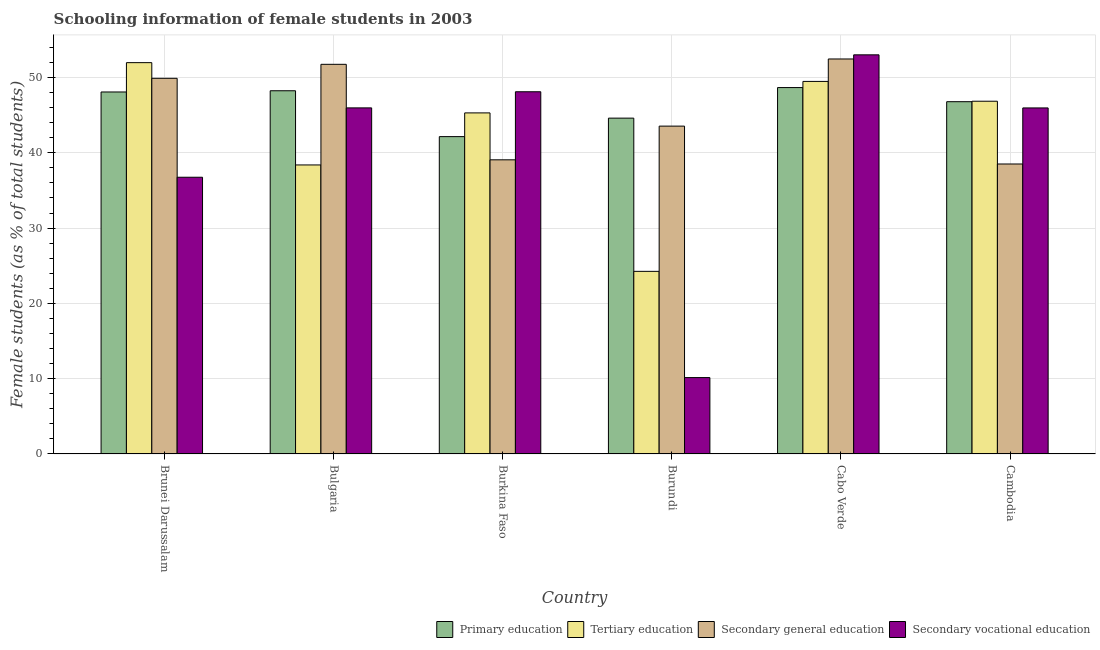How many different coloured bars are there?
Make the answer very short. 4. How many groups of bars are there?
Your response must be concise. 6. Are the number of bars on each tick of the X-axis equal?
Offer a very short reply. Yes. How many bars are there on the 5th tick from the left?
Offer a terse response. 4. What is the label of the 6th group of bars from the left?
Ensure brevity in your answer.  Cambodia. What is the percentage of female students in tertiary education in Cambodia?
Your answer should be compact. 46.85. Across all countries, what is the maximum percentage of female students in secondary vocational education?
Offer a very short reply. 53.01. Across all countries, what is the minimum percentage of female students in secondary education?
Give a very brief answer. 38.51. In which country was the percentage of female students in secondary education maximum?
Your answer should be compact. Cabo Verde. In which country was the percentage of female students in secondary education minimum?
Keep it short and to the point. Cambodia. What is the total percentage of female students in tertiary education in the graph?
Provide a short and direct response. 256.22. What is the difference between the percentage of female students in secondary education in Bulgaria and that in Burkina Faso?
Make the answer very short. 12.68. What is the difference between the percentage of female students in tertiary education in Burundi and the percentage of female students in primary education in Cabo Verde?
Make the answer very short. -24.41. What is the average percentage of female students in primary education per country?
Your response must be concise. 46.42. What is the difference between the percentage of female students in secondary education and percentage of female students in secondary vocational education in Cabo Verde?
Keep it short and to the point. -0.55. What is the ratio of the percentage of female students in secondary vocational education in Cabo Verde to that in Cambodia?
Your answer should be very brief. 1.15. What is the difference between the highest and the second highest percentage of female students in secondary education?
Keep it short and to the point. 0.71. What is the difference between the highest and the lowest percentage of female students in secondary education?
Your response must be concise. 13.95. Is it the case that in every country, the sum of the percentage of female students in secondary vocational education and percentage of female students in tertiary education is greater than the sum of percentage of female students in primary education and percentage of female students in secondary education?
Make the answer very short. No. What does the 4th bar from the left in Cambodia represents?
Your response must be concise. Secondary vocational education. What does the 3rd bar from the right in Cambodia represents?
Your answer should be very brief. Tertiary education. How many bars are there?
Provide a succinct answer. 24. What is the difference between two consecutive major ticks on the Y-axis?
Keep it short and to the point. 10. Are the values on the major ticks of Y-axis written in scientific E-notation?
Offer a very short reply. No. Does the graph contain grids?
Give a very brief answer. Yes. Where does the legend appear in the graph?
Offer a very short reply. Bottom right. How many legend labels are there?
Offer a terse response. 4. What is the title of the graph?
Ensure brevity in your answer.  Schooling information of female students in 2003. Does "Fish species" appear as one of the legend labels in the graph?
Your response must be concise. No. What is the label or title of the Y-axis?
Keep it short and to the point. Female students (as % of total students). What is the Female students (as % of total students) in Primary education in Brunei Darussalam?
Offer a very short reply. 48.07. What is the Female students (as % of total students) in Tertiary education in Brunei Darussalam?
Your answer should be very brief. 51.97. What is the Female students (as % of total students) of Secondary general education in Brunei Darussalam?
Provide a short and direct response. 49.89. What is the Female students (as % of total students) of Secondary vocational education in Brunei Darussalam?
Give a very brief answer. 36.75. What is the Female students (as % of total students) in Primary education in Bulgaria?
Your answer should be compact. 48.24. What is the Female students (as % of total students) in Tertiary education in Bulgaria?
Give a very brief answer. 38.38. What is the Female students (as % of total students) of Secondary general education in Bulgaria?
Your response must be concise. 51.75. What is the Female students (as % of total students) in Secondary vocational education in Bulgaria?
Your answer should be compact. 45.96. What is the Female students (as % of total students) of Primary education in Burkina Faso?
Make the answer very short. 42.15. What is the Female students (as % of total students) in Tertiary education in Burkina Faso?
Make the answer very short. 45.29. What is the Female students (as % of total students) in Secondary general education in Burkina Faso?
Offer a very short reply. 39.06. What is the Female students (as % of total students) in Secondary vocational education in Burkina Faso?
Provide a short and direct response. 48.1. What is the Female students (as % of total students) of Primary education in Burundi?
Your answer should be compact. 44.6. What is the Female students (as % of total students) in Tertiary education in Burundi?
Offer a terse response. 24.25. What is the Female students (as % of total students) of Secondary general education in Burundi?
Provide a short and direct response. 43.54. What is the Female students (as % of total students) in Secondary vocational education in Burundi?
Offer a very short reply. 10.14. What is the Female students (as % of total students) of Primary education in Cabo Verde?
Your answer should be compact. 48.66. What is the Female students (as % of total students) of Tertiary education in Cabo Verde?
Your response must be concise. 49.48. What is the Female students (as % of total students) of Secondary general education in Cabo Verde?
Offer a very short reply. 52.46. What is the Female students (as % of total students) in Secondary vocational education in Cabo Verde?
Offer a very short reply. 53.01. What is the Female students (as % of total students) in Primary education in Cambodia?
Make the answer very short. 46.78. What is the Female students (as % of total students) in Tertiary education in Cambodia?
Provide a succinct answer. 46.85. What is the Female students (as % of total students) of Secondary general education in Cambodia?
Your answer should be very brief. 38.51. What is the Female students (as % of total students) of Secondary vocational education in Cambodia?
Provide a succinct answer. 45.96. Across all countries, what is the maximum Female students (as % of total students) in Primary education?
Provide a short and direct response. 48.66. Across all countries, what is the maximum Female students (as % of total students) of Tertiary education?
Keep it short and to the point. 51.97. Across all countries, what is the maximum Female students (as % of total students) of Secondary general education?
Keep it short and to the point. 52.46. Across all countries, what is the maximum Female students (as % of total students) in Secondary vocational education?
Offer a very short reply. 53.01. Across all countries, what is the minimum Female students (as % of total students) of Primary education?
Keep it short and to the point. 42.15. Across all countries, what is the minimum Female students (as % of total students) in Tertiary education?
Offer a very short reply. 24.25. Across all countries, what is the minimum Female students (as % of total students) in Secondary general education?
Provide a succinct answer. 38.51. Across all countries, what is the minimum Female students (as % of total students) of Secondary vocational education?
Give a very brief answer. 10.14. What is the total Female students (as % of total students) in Primary education in the graph?
Offer a terse response. 278.5. What is the total Female students (as % of total students) in Tertiary education in the graph?
Your answer should be very brief. 256.22. What is the total Female students (as % of total students) of Secondary general education in the graph?
Your answer should be very brief. 275.21. What is the total Female students (as % of total students) in Secondary vocational education in the graph?
Offer a terse response. 239.92. What is the difference between the Female students (as % of total students) in Primary education in Brunei Darussalam and that in Bulgaria?
Offer a very short reply. -0.16. What is the difference between the Female students (as % of total students) of Tertiary education in Brunei Darussalam and that in Bulgaria?
Keep it short and to the point. 13.59. What is the difference between the Female students (as % of total students) of Secondary general education in Brunei Darussalam and that in Bulgaria?
Provide a succinct answer. -1.86. What is the difference between the Female students (as % of total students) of Secondary vocational education in Brunei Darussalam and that in Bulgaria?
Your answer should be compact. -9.21. What is the difference between the Female students (as % of total students) of Primary education in Brunei Darussalam and that in Burkina Faso?
Your response must be concise. 5.93. What is the difference between the Female students (as % of total students) of Tertiary education in Brunei Darussalam and that in Burkina Faso?
Make the answer very short. 6.67. What is the difference between the Female students (as % of total students) in Secondary general education in Brunei Darussalam and that in Burkina Faso?
Make the answer very short. 10.83. What is the difference between the Female students (as % of total students) in Secondary vocational education in Brunei Darussalam and that in Burkina Faso?
Ensure brevity in your answer.  -11.35. What is the difference between the Female students (as % of total students) of Primary education in Brunei Darussalam and that in Burundi?
Your answer should be compact. 3.47. What is the difference between the Female students (as % of total students) of Tertiary education in Brunei Darussalam and that in Burundi?
Your answer should be compact. 27.72. What is the difference between the Female students (as % of total students) in Secondary general education in Brunei Darussalam and that in Burundi?
Make the answer very short. 6.35. What is the difference between the Female students (as % of total students) of Secondary vocational education in Brunei Darussalam and that in Burundi?
Provide a succinct answer. 26.61. What is the difference between the Female students (as % of total students) of Primary education in Brunei Darussalam and that in Cabo Verde?
Provide a short and direct response. -0.59. What is the difference between the Female students (as % of total students) of Tertiary education in Brunei Darussalam and that in Cabo Verde?
Ensure brevity in your answer.  2.49. What is the difference between the Female students (as % of total students) of Secondary general education in Brunei Darussalam and that in Cabo Verde?
Make the answer very short. -2.57. What is the difference between the Female students (as % of total students) of Secondary vocational education in Brunei Darussalam and that in Cabo Verde?
Your answer should be compact. -16.26. What is the difference between the Female students (as % of total students) in Primary education in Brunei Darussalam and that in Cambodia?
Your answer should be compact. 1.29. What is the difference between the Female students (as % of total students) of Tertiary education in Brunei Darussalam and that in Cambodia?
Keep it short and to the point. 5.12. What is the difference between the Female students (as % of total students) in Secondary general education in Brunei Darussalam and that in Cambodia?
Ensure brevity in your answer.  11.38. What is the difference between the Female students (as % of total students) in Secondary vocational education in Brunei Darussalam and that in Cambodia?
Ensure brevity in your answer.  -9.21. What is the difference between the Female students (as % of total students) of Primary education in Bulgaria and that in Burkina Faso?
Provide a short and direct response. 6.09. What is the difference between the Female students (as % of total students) in Tertiary education in Bulgaria and that in Burkina Faso?
Make the answer very short. -6.91. What is the difference between the Female students (as % of total students) of Secondary general education in Bulgaria and that in Burkina Faso?
Provide a short and direct response. 12.68. What is the difference between the Female students (as % of total students) in Secondary vocational education in Bulgaria and that in Burkina Faso?
Keep it short and to the point. -2.14. What is the difference between the Female students (as % of total students) of Primary education in Bulgaria and that in Burundi?
Your answer should be compact. 3.63. What is the difference between the Female students (as % of total students) in Tertiary education in Bulgaria and that in Burundi?
Provide a succinct answer. 14.13. What is the difference between the Female students (as % of total students) in Secondary general education in Bulgaria and that in Burundi?
Make the answer very short. 8.21. What is the difference between the Female students (as % of total students) in Secondary vocational education in Bulgaria and that in Burundi?
Your response must be concise. 35.82. What is the difference between the Female students (as % of total students) in Primary education in Bulgaria and that in Cabo Verde?
Ensure brevity in your answer.  -0.42. What is the difference between the Female students (as % of total students) in Tertiary education in Bulgaria and that in Cabo Verde?
Give a very brief answer. -11.09. What is the difference between the Female students (as % of total students) in Secondary general education in Bulgaria and that in Cabo Verde?
Ensure brevity in your answer.  -0.71. What is the difference between the Female students (as % of total students) of Secondary vocational education in Bulgaria and that in Cabo Verde?
Provide a succinct answer. -7.05. What is the difference between the Female students (as % of total students) of Primary education in Bulgaria and that in Cambodia?
Your answer should be very brief. 1.45. What is the difference between the Female students (as % of total students) of Tertiary education in Bulgaria and that in Cambodia?
Your answer should be very brief. -8.46. What is the difference between the Female students (as % of total students) in Secondary general education in Bulgaria and that in Cambodia?
Ensure brevity in your answer.  13.24. What is the difference between the Female students (as % of total students) in Secondary vocational education in Bulgaria and that in Cambodia?
Ensure brevity in your answer.  0. What is the difference between the Female students (as % of total students) in Primary education in Burkina Faso and that in Burundi?
Ensure brevity in your answer.  -2.45. What is the difference between the Female students (as % of total students) in Tertiary education in Burkina Faso and that in Burundi?
Your response must be concise. 21.04. What is the difference between the Female students (as % of total students) of Secondary general education in Burkina Faso and that in Burundi?
Make the answer very short. -4.48. What is the difference between the Female students (as % of total students) in Secondary vocational education in Burkina Faso and that in Burundi?
Offer a very short reply. 37.96. What is the difference between the Female students (as % of total students) of Primary education in Burkina Faso and that in Cabo Verde?
Keep it short and to the point. -6.51. What is the difference between the Female students (as % of total students) of Tertiary education in Burkina Faso and that in Cabo Verde?
Keep it short and to the point. -4.18. What is the difference between the Female students (as % of total students) in Secondary general education in Burkina Faso and that in Cabo Verde?
Provide a short and direct response. -13.39. What is the difference between the Female students (as % of total students) in Secondary vocational education in Burkina Faso and that in Cabo Verde?
Offer a very short reply. -4.9. What is the difference between the Female students (as % of total students) in Primary education in Burkina Faso and that in Cambodia?
Your answer should be compact. -4.64. What is the difference between the Female students (as % of total students) of Tertiary education in Burkina Faso and that in Cambodia?
Make the answer very short. -1.55. What is the difference between the Female students (as % of total students) in Secondary general education in Burkina Faso and that in Cambodia?
Provide a succinct answer. 0.55. What is the difference between the Female students (as % of total students) in Secondary vocational education in Burkina Faso and that in Cambodia?
Provide a succinct answer. 2.15. What is the difference between the Female students (as % of total students) of Primary education in Burundi and that in Cabo Verde?
Offer a very short reply. -4.06. What is the difference between the Female students (as % of total students) of Tertiary education in Burundi and that in Cabo Verde?
Your answer should be compact. -25.23. What is the difference between the Female students (as % of total students) of Secondary general education in Burundi and that in Cabo Verde?
Your answer should be compact. -8.92. What is the difference between the Female students (as % of total students) in Secondary vocational education in Burundi and that in Cabo Verde?
Provide a short and direct response. -42.86. What is the difference between the Female students (as % of total students) of Primary education in Burundi and that in Cambodia?
Your answer should be compact. -2.18. What is the difference between the Female students (as % of total students) in Tertiary education in Burundi and that in Cambodia?
Your answer should be very brief. -22.59. What is the difference between the Female students (as % of total students) in Secondary general education in Burundi and that in Cambodia?
Your answer should be very brief. 5.03. What is the difference between the Female students (as % of total students) in Secondary vocational education in Burundi and that in Cambodia?
Provide a short and direct response. -35.81. What is the difference between the Female students (as % of total students) of Primary education in Cabo Verde and that in Cambodia?
Provide a succinct answer. 1.88. What is the difference between the Female students (as % of total students) in Tertiary education in Cabo Verde and that in Cambodia?
Ensure brevity in your answer.  2.63. What is the difference between the Female students (as % of total students) in Secondary general education in Cabo Verde and that in Cambodia?
Your response must be concise. 13.95. What is the difference between the Female students (as % of total students) in Secondary vocational education in Cabo Verde and that in Cambodia?
Provide a short and direct response. 7.05. What is the difference between the Female students (as % of total students) of Primary education in Brunei Darussalam and the Female students (as % of total students) of Tertiary education in Bulgaria?
Provide a short and direct response. 9.69. What is the difference between the Female students (as % of total students) in Primary education in Brunei Darussalam and the Female students (as % of total students) in Secondary general education in Bulgaria?
Your answer should be very brief. -3.67. What is the difference between the Female students (as % of total students) of Primary education in Brunei Darussalam and the Female students (as % of total students) of Secondary vocational education in Bulgaria?
Offer a very short reply. 2.11. What is the difference between the Female students (as % of total students) in Tertiary education in Brunei Darussalam and the Female students (as % of total students) in Secondary general education in Bulgaria?
Keep it short and to the point. 0.22. What is the difference between the Female students (as % of total students) of Tertiary education in Brunei Darussalam and the Female students (as % of total students) of Secondary vocational education in Bulgaria?
Your response must be concise. 6.01. What is the difference between the Female students (as % of total students) of Secondary general education in Brunei Darussalam and the Female students (as % of total students) of Secondary vocational education in Bulgaria?
Ensure brevity in your answer.  3.93. What is the difference between the Female students (as % of total students) in Primary education in Brunei Darussalam and the Female students (as % of total students) in Tertiary education in Burkina Faso?
Your response must be concise. 2.78. What is the difference between the Female students (as % of total students) of Primary education in Brunei Darussalam and the Female students (as % of total students) of Secondary general education in Burkina Faso?
Offer a very short reply. 9.01. What is the difference between the Female students (as % of total students) in Primary education in Brunei Darussalam and the Female students (as % of total students) in Secondary vocational education in Burkina Faso?
Ensure brevity in your answer.  -0.03. What is the difference between the Female students (as % of total students) in Tertiary education in Brunei Darussalam and the Female students (as % of total students) in Secondary general education in Burkina Faso?
Keep it short and to the point. 12.9. What is the difference between the Female students (as % of total students) in Tertiary education in Brunei Darussalam and the Female students (as % of total students) in Secondary vocational education in Burkina Faso?
Provide a succinct answer. 3.87. What is the difference between the Female students (as % of total students) in Secondary general education in Brunei Darussalam and the Female students (as % of total students) in Secondary vocational education in Burkina Faso?
Make the answer very short. 1.79. What is the difference between the Female students (as % of total students) in Primary education in Brunei Darussalam and the Female students (as % of total students) in Tertiary education in Burundi?
Make the answer very short. 23.82. What is the difference between the Female students (as % of total students) in Primary education in Brunei Darussalam and the Female students (as % of total students) in Secondary general education in Burundi?
Provide a short and direct response. 4.53. What is the difference between the Female students (as % of total students) in Primary education in Brunei Darussalam and the Female students (as % of total students) in Secondary vocational education in Burundi?
Your response must be concise. 37.93. What is the difference between the Female students (as % of total students) in Tertiary education in Brunei Darussalam and the Female students (as % of total students) in Secondary general education in Burundi?
Your response must be concise. 8.43. What is the difference between the Female students (as % of total students) in Tertiary education in Brunei Darussalam and the Female students (as % of total students) in Secondary vocational education in Burundi?
Give a very brief answer. 41.82. What is the difference between the Female students (as % of total students) in Secondary general education in Brunei Darussalam and the Female students (as % of total students) in Secondary vocational education in Burundi?
Give a very brief answer. 39.75. What is the difference between the Female students (as % of total students) in Primary education in Brunei Darussalam and the Female students (as % of total students) in Tertiary education in Cabo Verde?
Give a very brief answer. -1.4. What is the difference between the Female students (as % of total students) of Primary education in Brunei Darussalam and the Female students (as % of total students) of Secondary general education in Cabo Verde?
Provide a succinct answer. -4.38. What is the difference between the Female students (as % of total students) of Primary education in Brunei Darussalam and the Female students (as % of total students) of Secondary vocational education in Cabo Verde?
Your answer should be compact. -4.93. What is the difference between the Female students (as % of total students) of Tertiary education in Brunei Darussalam and the Female students (as % of total students) of Secondary general education in Cabo Verde?
Keep it short and to the point. -0.49. What is the difference between the Female students (as % of total students) in Tertiary education in Brunei Darussalam and the Female students (as % of total students) in Secondary vocational education in Cabo Verde?
Ensure brevity in your answer.  -1.04. What is the difference between the Female students (as % of total students) of Secondary general education in Brunei Darussalam and the Female students (as % of total students) of Secondary vocational education in Cabo Verde?
Offer a very short reply. -3.12. What is the difference between the Female students (as % of total students) of Primary education in Brunei Darussalam and the Female students (as % of total students) of Tertiary education in Cambodia?
Your response must be concise. 1.23. What is the difference between the Female students (as % of total students) of Primary education in Brunei Darussalam and the Female students (as % of total students) of Secondary general education in Cambodia?
Ensure brevity in your answer.  9.56. What is the difference between the Female students (as % of total students) in Primary education in Brunei Darussalam and the Female students (as % of total students) in Secondary vocational education in Cambodia?
Offer a terse response. 2.12. What is the difference between the Female students (as % of total students) of Tertiary education in Brunei Darussalam and the Female students (as % of total students) of Secondary general education in Cambodia?
Offer a very short reply. 13.46. What is the difference between the Female students (as % of total students) of Tertiary education in Brunei Darussalam and the Female students (as % of total students) of Secondary vocational education in Cambodia?
Your response must be concise. 6.01. What is the difference between the Female students (as % of total students) in Secondary general education in Brunei Darussalam and the Female students (as % of total students) in Secondary vocational education in Cambodia?
Keep it short and to the point. 3.93. What is the difference between the Female students (as % of total students) in Primary education in Bulgaria and the Female students (as % of total students) in Tertiary education in Burkina Faso?
Give a very brief answer. 2.94. What is the difference between the Female students (as % of total students) of Primary education in Bulgaria and the Female students (as % of total students) of Secondary general education in Burkina Faso?
Your answer should be very brief. 9.17. What is the difference between the Female students (as % of total students) in Primary education in Bulgaria and the Female students (as % of total students) in Secondary vocational education in Burkina Faso?
Offer a terse response. 0.13. What is the difference between the Female students (as % of total students) of Tertiary education in Bulgaria and the Female students (as % of total students) of Secondary general education in Burkina Faso?
Give a very brief answer. -0.68. What is the difference between the Female students (as % of total students) of Tertiary education in Bulgaria and the Female students (as % of total students) of Secondary vocational education in Burkina Faso?
Provide a succinct answer. -9.72. What is the difference between the Female students (as % of total students) of Secondary general education in Bulgaria and the Female students (as % of total students) of Secondary vocational education in Burkina Faso?
Ensure brevity in your answer.  3.64. What is the difference between the Female students (as % of total students) of Primary education in Bulgaria and the Female students (as % of total students) of Tertiary education in Burundi?
Your response must be concise. 23.98. What is the difference between the Female students (as % of total students) of Primary education in Bulgaria and the Female students (as % of total students) of Secondary general education in Burundi?
Your answer should be compact. 4.69. What is the difference between the Female students (as % of total students) of Primary education in Bulgaria and the Female students (as % of total students) of Secondary vocational education in Burundi?
Make the answer very short. 38.09. What is the difference between the Female students (as % of total students) of Tertiary education in Bulgaria and the Female students (as % of total students) of Secondary general education in Burundi?
Offer a very short reply. -5.16. What is the difference between the Female students (as % of total students) of Tertiary education in Bulgaria and the Female students (as % of total students) of Secondary vocational education in Burundi?
Give a very brief answer. 28.24. What is the difference between the Female students (as % of total students) in Secondary general education in Bulgaria and the Female students (as % of total students) in Secondary vocational education in Burundi?
Your answer should be very brief. 41.6. What is the difference between the Female students (as % of total students) of Primary education in Bulgaria and the Female students (as % of total students) of Tertiary education in Cabo Verde?
Offer a very short reply. -1.24. What is the difference between the Female students (as % of total students) in Primary education in Bulgaria and the Female students (as % of total students) in Secondary general education in Cabo Verde?
Your answer should be very brief. -4.22. What is the difference between the Female students (as % of total students) of Primary education in Bulgaria and the Female students (as % of total students) of Secondary vocational education in Cabo Verde?
Your answer should be compact. -4.77. What is the difference between the Female students (as % of total students) of Tertiary education in Bulgaria and the Female students (as % of total students) of Secondary general education in Cabo Verde?
Your answer should be very brief. -14.07. What is the difference between the Female students (as % of total students) in Tertiary education in Bulgaria and the Female students (as % of total students) in Secondary vocational education in Cabo Verde?
Keep it short and to the point. -14.62. What is the difference between the Female students (as % of total students) in Secondary general education in Bulgaria and the Female students (as % of total students) in Secondary vocational education in Cabo Verde?
Offer a terse response. -1.26. What is the difference between the Female students (as % of total students) of Primary education in Bulgaria and the Female students (as % of total students) of Tertiary education in Cambodia?
Provide a short and direct response. 1.39. What is the difference between the Female students (as % of total students) of Primary education in Bulgaria and the Female students (as % of total students) of Secondary general education in Cambodia?
Your response must be concise. 9.73. What is the difference between the Female students (as % of total students) of Primary education in Bulgaria and the Female students (as % of total students) of Secondary vocational education in Cambodia?
Provide a short and direct response. 2.28. What is the difference between the Female students (as % of total students) of Tertiary education in Bulgaria and the Female students (as % of total students) of Secondary general education in Cambodia?
Offer a terse response. -0.13. What is the difference between the Female students (as % of total students) in Tertiary education in Bulgaria and the Female students (as % of total students) in Secondary vocational education in Cambodia?
Your answer should be very brief. -7.57. What is the difference between the Female students (as % of total students) in Secondary general education in Bulgaria and the Female students (as % of total students) in Secondary vocational education in Cambodia?
Your answer should be very brief. 5.79. What is the difference between the Female students (as % of total students) of Primary education in Burkina Faso and the Female students (as % of total students) of Tertiary education in Burundi?
Provide a short and direct response. 17.89. What is the difference between the Female students (as % of total students) in Primary education in Burkina Faso and the Female students (as % of total students) in Secondary general education in Burundi?
Your response must be concise. -1.4. What is the difference between the Female students (as % of total students) of Primary education in Burkina Faso and the Female students (as % of total students) of Secondary vocational education in Burundi?
Offer a terse response. 32. What is the difference between the Female students (as % of total students) of Tertiary education in Burkina Faso and the Female students (as % of total students) of Secondary general education in Burundi?
Keep it short and to the point. 1.75. What is the difference between the Female students (as % of total students) in Tertiary education in Burkina Faso and the Female students (as % of total students) in Secondary vocational education in Burundi?
Make the answer very short. 35.15. What is the difference between the Female students (as % of total students) of Secondary general education in Burkina Faso and the Female students (as % of total students) of Secondary vocational education in Burundi?
Your response must be concise. 28.92. What is the difference between the Female students (as % of total students) of Primary education in Burkina Faso and the Female students (as % of total students) of Tertiary education in Cabo Verde?
Offer a very short reply. -7.33. What is the difference between the Female students (as % of total students) in Primary education in Burkina Faso and the Female students (as % of total students) in Secondary general education in Cabo Verde?
Give a very brief answer. -10.31. What is the difference between the Female students (as % of total students) in Primary education in Burkina Faso and the Female students (as % of total students) in Secondary vocational education in Cabo Verde?
Keep it short and to the point. -10.86. What is the difference between the Female students (as % of total students) of Tertiary education in Burkina Faso and the Female students (as % of total students) of Secondary general education in Cabo Verde?
Provide a short and direct response. -7.16. What is the difference between the Female students (as % of total students) in Tertiary education in Burkina Faso and the Female students (as % of total students) in Secondary vocational education in Cabo Verde?
Your answer should be very brief. -7.71. What is the difference between the Female students (as % of total students) of Secondary general education in Burkina Faso and the Female students (as % of total students) of Secondary vocational education in Cabo Verde?
Keep it short and to the point. -13.94. What is the difference between the Female students (as % of total students) of Primary education in Burkina Faso and the Female students (as % of total students) of Tertiary education in Cambodia?
Offer a terse response. -4.7. What is the difference between the Female students (as % of total students) of Primary education in Burkina Faso and the Female students (as % of total students) of Secondary general education in Cambodia?
Give a very brief answer. 3.64. What is the difference between the Female students (as % of total students) of Primary education in Burkina Faso and the Female students (as % of total students) of Secondary vocational education in Cambodia?
Make the answer very short. -3.81. What is the difference between the Female students (as % of total students) of Tertiary education in Burkina Faso and the Female students (as % of total students) of Secondary general education in Cambodia?
Your response must be concise. 6.79. What is the difference between the Female students (as % of total students) of Tertiary education in Burkina Faso and the Female students (as % of total students) of Secondary vocational education in Cambodia?
Ensure brevity in your answer.  -0.66. What is the difference between the Female students (as % of total students) of Secondary general education in Burkina Faso and the Female students (as % of total students) of Secondary vocational education in Cambodia?
Your answer should be compact. -6.89. What is the difference between the Female students (as % of total students) in Primary education in Burundi and the Female students (as % of total students) in Tertiary education in Cabo Verde?
Make the answer very short. -4.88. What is the difference between the Female students (as % of total students) in Primary education in Burundi and the Female students (as % of total students) in Secondary general education in Cabo Verde?
Offer a very short reply. -7.86. What is the difference between the Female students (as % of total students) of Primary education in Burundi and the Female students (as % of total students) of Secondary vocational education in Cabo Verde?
Provide a succinct answer. -8.41. What is the difference between the Female students (as % of total students) of Tertiary education in Burundi and the Female students (as % of total students) of Secondary general education in Cabo Verde?
Offer a very short reply. -28.2. What is the difference between the Female students (as % of total students) of Tertiary education in Burundi and the Female students (as % of total students) of Secondary vocational education in Cabo Verde?
Make the answer very short. -28.76. What is the difference between the Female students (as % of total students) in Secondary general education in Burundi and the Female students (as % of total students) in Secondary vocational education in Cabo Verde?
Make the answer very short. -9.47. What is the difference between the Female students (as % of total students) of Primary education in Burundi and the Female students (as % of total students) of Tertiary education in Cambodia?
Your answer should be compact. -2.24. What is the difference between the Female students (as % of total students) of Primary education in Burundi and the Female students (as % of total students) of Secondary general education in Cambodia?
Offer a very short reply. 6.09. What is the difference between the Female students (as % of total students) in Primary education in Burundi and the Female students (as % of total students) in Secondary vocational education in Cambodia?
Give a very brief answer. -1.36. What is the difference between the Female students (as % of total students) of Tertiary education in Burundi and the Female students (as % of total students) of Secondary general education in Cambodia?
Give a very brief answer. -14.26. What is the difference between the Female students (as % of total students) in Tertiary education in Burundi and the Female students (as % of total students) in Secondary vocational education in Cambodia?
Your response must be concise. -21.7. What is the difference between the Female students (as % of total students) in Secondary general education in Burundi and the Female students (as % of total students) in Secondary vocational education in Cambodia?
Your answer should be very brief. -2.42. What is the difference between the Female students (as % of total students) of Primary education in Cabo Verde and the Female students (as % of total students) of Tertiary education in Cambodia?
Provide a succinct answer. 1.81. What is the difference between the Female students (as % of total students) of Primary education in Cabo Verde and the Female students (as % of total students) of Secondary general education in Cambodia?
Keep it short and to the point. 10.15. What is the difference between the Female students (as % of total students) in Primary education in Cabo Verde and the Female students (as % of total students) in Secondary vocational education in Cambodia?
Offer a terse response. 2.7. What is the difference between the Female students (as % of total students) of Tertiary education in Cabo Verde and the Female students (as % of total students) of Secondary general education in Cambodia?
Keep it short and to the point. 10.97. What is the difference between the Female students (as % of total students) in Tertiary education in Cabo Verde and the Female students (as % of total students) in Secondary vocational education in Cambodia?
Provide a succinct answer. 3.52. What is the difference between the Female students (as % of total students) in Secondary general education in Cabo Verde and the Female students (as % of total students) in Secondary vocational education in Cambodia?
Provide a short and direct response. 6.5. What is the average Female students (as % of total students) of Primary education per country?
Your response must be concise. 46.42. What is the average Female students (as % of total students) in Tertiary education per country?
Offer a terse response. 42.7. What is the average Female students (as % of total students) of Secondary general education per country?
Provide a succinct answer. 45.87. What is the average Female students (as % of total students) in Secondary vocational education per country?
Your answer should be compact. 39.99. What is the difference between the Female students (as % of total students) of Primary education and Female students (as % of total students) of Tertiary education in Brunei Darussalam?
Make the answer very short. -3.9. What is the difference between the Female students (as % of total students) of Primary education and Female students (as % of total students) of Secondary general education in Brunei Darussalam?
Keep it short and to the point. -1.82. What is the difference between the Female students (as % of total students) of Primary education and Female students (as % of total students) of Secondary vocational education in Brunei Darussalam?
Offer a terse response. 11.32. What is the difference between the Female students (as % of total students) in Tertiary education and Female students (as % of total students) in Secondary general education in Brunei Darussalam?
Provide a short and direct response. 2.08. What is the difference between the Female students (as % of total students) of Tertiary education and Female students (as % of total students) of Secondary vocational education in Brunei Darussalam?
Make the answer very short. 15.22. What is the difference between the Female students (as % of total students) of Secondary general education and Female students (as % of total students) of Secondary vocational education in Brunei Darussalam?
Provide a succinct answer. 13.14. What is the difference between the Female students (as % of total students) in Primary education and Female students (as % of total students) in Tertiary education in Bulgaria?
Your answer should be compact. 9.85. What is the difference between the Female students (as % of total students) of Primary education and Female students (as % of total students) of Secondary general education in Bulgaria?
Make the answer very short. -3.51. What is the difference between the Female students (as % of total students) of Primary education and Female students (as % of total students) of Secondary vocational education in Bulgaria?
Provide a succinct answer. 2.27. What is the difference between the Female students (as % of total students) in Tertiary education and Female students (as % of total students) in Secondary general education in Bulgaria?
Keep it short and to the point. -13.36. What is the difference between the Female students (as % of total students) in Tertiary education and Female students (as % of total students) in Secondary vocational education in Bulgaria?
Ensure brevity in your answer.  -7.58. What is the difference between the Female students (as % of total students) in Secondary general education and Female students (as % of total students) in Secondary vocational education in Bulgaria?
Offer a terse response. 5.79. What is the difference between the Female students (as % of total students) of Primary education and Female students (as % of total students) of Tertiary education in Burkina Faso?
Ensure brevity in your answer.  -3.15. What is the difference between the Female students (as % of total students) of Primary education and Female students (as % of total students) of Secondary general education in Burkina Faso?
Your answer should be very brief. 3.08. What is the difference between the Female students (as % of total students) in Primary education and Female students (as % of total students) in Secondary vocational education in Burkina Faso?
Your response must be concise. -5.96. What is the difference between the Female students (as % of total students) in Tertiary education and Female students (as % of total students) in Secondary general education in Burkina Faso?
Your answer should be very brief. 6.23. What is the difference between the Female students (as % of total students) in Tertiary education and Female students (as % of total students) in Secondary vocational education in Burkina Faso?
Provide a short and direct response. -2.81. What is the difference between the Female students (as % of total students) in Secondary general education and Female students (as % of total students) in Secondary vocational education in Burkina Faso?
Make the answer very short. -9.04. What is the difference between the Female students (as % of total students) in Primary education and Female students (as % of total students) in Tertiary education in Burundi?
Your response must be concise. 20.35. What is the difference between the Female students (as % of total students) in Primary education and Female students (as % of total students) in Secondary general education in Burundi?
Give a very brief answer. 1.06. What is the difference between the Female students (as % of total students) in Primary education and Female students (as % of total students) in Secondary vocational education in Burundi?
Ensure brevity in your answer.  34.46. What is the difference between the Female students (as % of total students) of Tertiary education and Female students (as % of total students) of Secondary general education in Burundi?
Your response must be concise. -19.29. What is the difference between the Female students (as % of total students) of Tertiary education and Female students (as % of total students) of Secondary vocational education in Burundi?
Offer a terse response. 14.11. What is the difference between the Female students (as % of total students) in Secondary general education and Female students (as % of total students) in Secondary vocational education in Burundi?
Your answer should be compact. 33.4. What is the difference between the Female students (as % of total students) of Primary education and Female students (as % of total students) of Tertiary education in Cabo Verde?
Keep it short and to the point. -0.82. What is the difference between the Female students (as % of total students) in Primary education and Female students (as % of total students) in Secondary general education in Cabo Verde?
Your answer should be compact. -3.8. What is the difference between the Female students (as % of total students) in Primary education and Female students (as % of total students) in Secondary vocational education in Cabo Verde?
Your answer should be very brief. -4.35. What is the difference between the Female students (as % of total students) of Tertiary education and Female students (as % of total students) of Secondary general education in Cabo Verde?
Your answer should be very brief. -2.98. What is the difference between the Female students (as % of total students) of Tertiary education and Female students (as % of total students) of Secondary vocational education in Cabo Verde?
Make the answer very short. -3.53. What is the difference between the Female students (as % of total students) of Secondary general education and Female students (as % of total students) of Secondary vocational education in Cabo Verde?
Make the answer very short. -0.55. What is the difference between the Female students (as % of total students) in Primary education and Female students (as % of total students) in Tertiary education in Cambodia?
Provide a short and direct response. -0.06. What is the difference between the Female students (as % of total students) in Primary education and Female students (as % of total students) in Secondary general education in Cambodia?
Give a very brief answer. 8.27. What is the difference between the Female students (as % of total students) in Primary education and Female students (as % of total students) in Secondary vocational education in Cambodia?
Give a very brief answer. 0.83. What is the difference between the Female students (as % of total students) in Tertiary education and Female students (as % of total students) in Secondary general education in Cambodia?
Ensure brevity in your answer.  8.34. What is the difference between the Female students (as % of total students) in Tertiary education and Female students (as % of total students) in Secondary vocational education in Cambodia?
Your answer should be very brief. 0.89. What is the difference between the Female students (as % of total students) of Secondary general education and Female students (as % of total students) of Secondary vocational education in Cambodia?
Keep it short and to the point. -7.45. What is the ratio of the Female students (as % of total students) of Tertiary education in Brunei Darussalam to that in Bulgaria?
Your response must be concise. 1.35. What is the ratio of the Female students (as % of total students) of Secondary general education in Brunei Darussalam to that in Bulgaria?
Keep it short and to the point. 0.96. What is the ratio of the Female students (as % of total students) of Secondary vocational education in Brunei Darussalam to that in Bulgaria?
Keep it short and to the point. 0.8. What is the ratio of the Female students (as % of total students) in Primary education in Brunei Darussalam to that in Burkina Faso?
Your response must be concise. 1.14. What is the ratio of the Female students (as % of total students) in Tertiary education in Brunei Darussalam to that in Burkina Faso?
Offer a very short reply. 1.15. What is the ratio of the Female students (as % of total students) in Secondary general education in Brunei Darussalam to that in Burkina Faso?
Keep it short and to the point. 1.28. What is the ratio of the Female students (as % of total students) in Secondary vocational education in Brunei Darussalam to that in Burkina Faso?
Offer a terse response. 0.76. What is the ratio of the Female students (as % of total students) of Primary education in Brunei Darussalam to that in Burundi?
Provide a succinct answer. 1.08. What is the ratio of the Female students (as % of total students) of Tertiary education in Brunei Darussalam to that in Burundi?
Your answer should be very brief. 2.14. What is the ratio of the Female students (as % of total students) of Secondary general education in Brunei Darussalam to that in Burundi?
Make the answer very short. 1.15. What is the ratio of the Female students (as % of total students) in Secondary vocational education in Brunei Darussalam to that in Burundi?
Make the answer very short. 3.62. What is the ratio of the Female students (as % of total students) in Primary education in Brunei Darussalam to that in Cabo Verde?
Your answer should be compact. 0.99. What is the ratio of the Female students (as % of total students) in Tertiary education in Brunei Darussalam to that in Cabo Verde?
Ensure brevity in your answer.  1.05. What is the ratio of the Female students (as % of total students) of Secondary general education in Brunei Darussalam to that in Cabo Verde?
Provide a succinct answer. 0.95. What is the ratio of the Female students (as % of total students) of Secondary vocational education in Brunei Darussalam to that in Cabo Verde?
Make the answer very short. 0.69. What is the ratio of the Female students (as % of total students) of Primary education in Brunei Darussalam to that in Cambodia?
Your response must be concise. 1.03. What is the ratio of the Female students (as % of total students) in Tertiary education in Brunei Darussalam to that in Cambodia?
Offer a very short reply. 1.11. What is the ratio of the Female students (as % of total students) in Secondary general education in Brunei Darussalam to that in Cambodia?
Your answer should be very brief. 1.3. What is the ratio of the Female students (as % of total students) of Secondary vocational education in Brunei Darussalam to that in Cambodia?
Your response must be concise. 0.8. What is the ratio of the Female students (as % of total students) of Primary education in Bulgaria to that in Burkina Faso?
Provide a short and direct response. 1.14. What is the ratio of the Female students (as % of total students) in Tertiary education in Bulgaria to that in Burkina Faso?
Offer a terse response. 0.85. What is the ratio of the Female students (as % of total students) in Secondary general education in Bulgaria to that in Burkina Faso?
Keep it short and to the point. 1.32. What is the ratio of the Female students (as % of total students) in Secondary vocational education in Bulgaria to that in Burkina Faso?
Offer a terse response. 0.96. What is the ratio of the Female students (as % of total students) in Primary education in Bulgaria to that in Burundi?
Ensure brevity in your answer.  1.08. What is the ratio of the Female students (as % of total students) in Tertiary education in Bulgaria to that in Burundi?
Make the answer very short. 1.58. What is the ratio of the Female students (as % of total students) in Secondary general education in Bulgaria to that in Burundi?
Offer a very short reply. 1.19. What is the ratio of the Female students (as % of total students) of Secondary vocational education in Bulgaria to that in Burundi?
Your answer should be compact. 4.53. What is the ratio of the Female students (as % of total students) of Primary education in Bulgaria to that in Cabo Verde?
Make the answer very short. 0.99. What is the ratio of the Female students (as % of total students) in Tertiary education in Bulgaria to that in Cabo Verde?
Your answer should be compact. 0.78. What is the ratio of the Female students (as % of total students) of Secondary general education in Bulgaria to that in Cabo Verde?
Give a very brief answer. 0.99. What is the ratio of the Female students (as % of total students) of Secondary vocational education in Bulgaria to that in Cabo Verde?
Your answer should be compact. 0.87. What is the ratio of the Female students (as % of total students) in Primary education in Bulgaria to that in Cambodia?
Make the answer very short. 1.03. What is the ratio of the Female students (as % of total students) of Tertiary education in Bulgaria to that in Cambodia?
Give a very brief answer. 0.82. What is the ratio of the Female students (as % of total students) of Secondary general education in Bulgaria to that in Cambodia?
Provide a short and direct response. 1.34. What is the ratio of the Female students (as % of total students) in Primary education in Burkina Faso to that in Burundi?
Keep it short and to the point. 0.94. What is the ratio of the Female students (as % of total students) in Tertiary education in Burkina Faso to that in Burundi?
Offer a very short reply. 1.87. What is the ratio of the Female students (as % of total students) of Secondary general education in Burkina Faso to that in Burundi?
Keep it short and to the point. 0.9. What is the ratio of the Female students (as % of total students) in Secondary vocational education in Burkina Faso to that in Burundi?
Provide a succinct answer. 4.74. What is the ratio of the Female students (as % of total students) in Primary education in Burkina Faso to that in Cabo Verde?
Offer a very short reply. 0.87. What is the ratio of the Female students (as % of total students) of Tertiary education in Burkina Faso to that in Cabo Verde?
Ensure brevity in your answer.  0.92. What is the ratio of the Female students (as % of total students) of Secondary general education in Burkina Faso to that in Cabo Verde?
Provide a short and direct response. 0.74. What is the ratio of the Female students (as % of total students) of Secondary vocational education in Burkina Faso to that in Cabo Verde?
Offer a terse response. 0.91. What is the ratio of the Female students (as % of total students) of Primary education in Burkina Faso to that in Cambodia?
Your answer should be very brief. 0.9. What is the ratio of the Female students (as % of total students) of Tertiary education in Burkina Faso to that in Cambodia?
Ensure brevity in your answer.  0.97. What is the ratio of the Female students (as % of total students) in Secondary general education in Burkina Faso to that in Cambodia?
Provide a succinct answer. 1.01. What is the ratio of the Female students (as % of total students) in Secondary vocational education in Burkina Faso to that in Cambodia?
Provide a succinct answer. 1.05. What is the ratio of the Female students (as % of total students) in Primary education in Burundi to that in Cabo Verde?
Make the answer very short. 0.92. What is the ratio of the Female students (as % of total students) of Tertiary education in Burundi to that in Cabo Verde?
Your response must be concise. 0.49. What is the ratio of the Female students (as % of total students) of Secondary general education in Burundi to that in Cabo Verde?
Your answer should be very brief. 0.83. What is the ratio of the Female students (as % of total students) in Secondary vocational education in Burundi to that in Cabo Verde?
Provide a succinct answer. 0.19. What is the ratio of the Female students (as % of total students) of Primary education in Burundi to that in Cambodia?
Ensure brevity in your answer.  0.95. What is the ratio of the Female students (as % of total students) in Tertiary education in Burundi to that in Cambodia?
Ensure brevity in your answer.  0.52. What is the ratio of the Female students (as % of total students) of Secondary general education in Burundi to that in Cambodia?
Keep it short and to the point. 1.13. What is the ratio of the Female students (as % of total students) of Secondary vocational education in Burundi to that in Cambodia?
Your answer should be very brief. 0.22. What is the ratio of the Female students (as % of total students) in Primary education in Cabo Verde to that in Cambodia?
Your response must be concise. 1.04. What is the ratio of the Female students (as % of total students) in Tertiary education in Cabo Verde to that in Cambodia?
Keep it short and to the point. 1.06. What is the ratio of the Female students (as % of total students) in Secondary general education in Cabo Verde to that in Cambodia?
Provide a succinct answer. 1.36. What is the ratio of the Female students (as % of total students) of Secondary vocational education in Cabo Verde to that in Cambodia?
Provide a succinct answer. 1.15. What is the difference between the highest and the second highest Female students (as % of total students) of Primary education?
Keep it short and to the point. 0.42. What is the difference between the highest and the second highest Female students (as % of total students) of Tertiary education?
Provide a succinct answer. 2.49. What is the difference between the highest and the second highest Female students (as % of total students) of Secondary general education?
Offer a terse response. 0.71. What is the difference between the highest and the second highest Female students (as % of total students) of Secondary vocational education?
Ensure brevity in your answer.  4.9. What is the difference between the highest and the lowest Female students (as % of total students) of Primary education?
Your answer should be compact. 6.51. What is the difference between the highest and the lowest Female students (as % of total students) of Tertiary education?
Your answer should be compact. 27.72. What is the difference between the highest and the lowest Female students (as % of total students) of Secondary general education?
Provide a short and direct response. 13.95. What is the difference between the highest and the lowest Female students (as % of total students) of Secondary vocational education?
Offer a terse response. 42.86. 